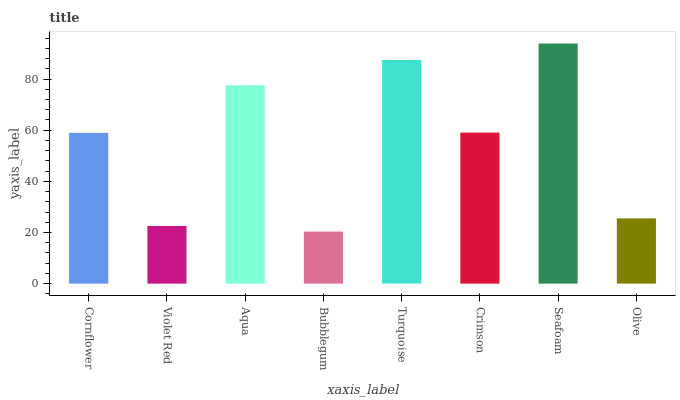Is Bubblegum the minimum?
Answer yes or no. Yes. Is Seafoam the maximum?
Answer yes or no. Yes. Is Violet Red the minimum?
Answer yes or no. No. Is Violet Red the maximum?
Answer yes or no. No. Is Cornflower greater than Violet Red?
Answer yes or no. Yes. Is Violet Red less than Cornflower?
Answer yes or no. Yes. Is Violet Red greater than Cornflower?
Answer yes or no. No. Is Cornflower less than Violet Red?
Answer yes or no. No. Is Crimson the high median?
Answer yes or no. Yes. Is Cornflower the low median?
Answer yes or no. Yes. Is Turquoise the high median?
Answer yes or no. No. Is Aqua the low median?
Answer yes or no. No. 